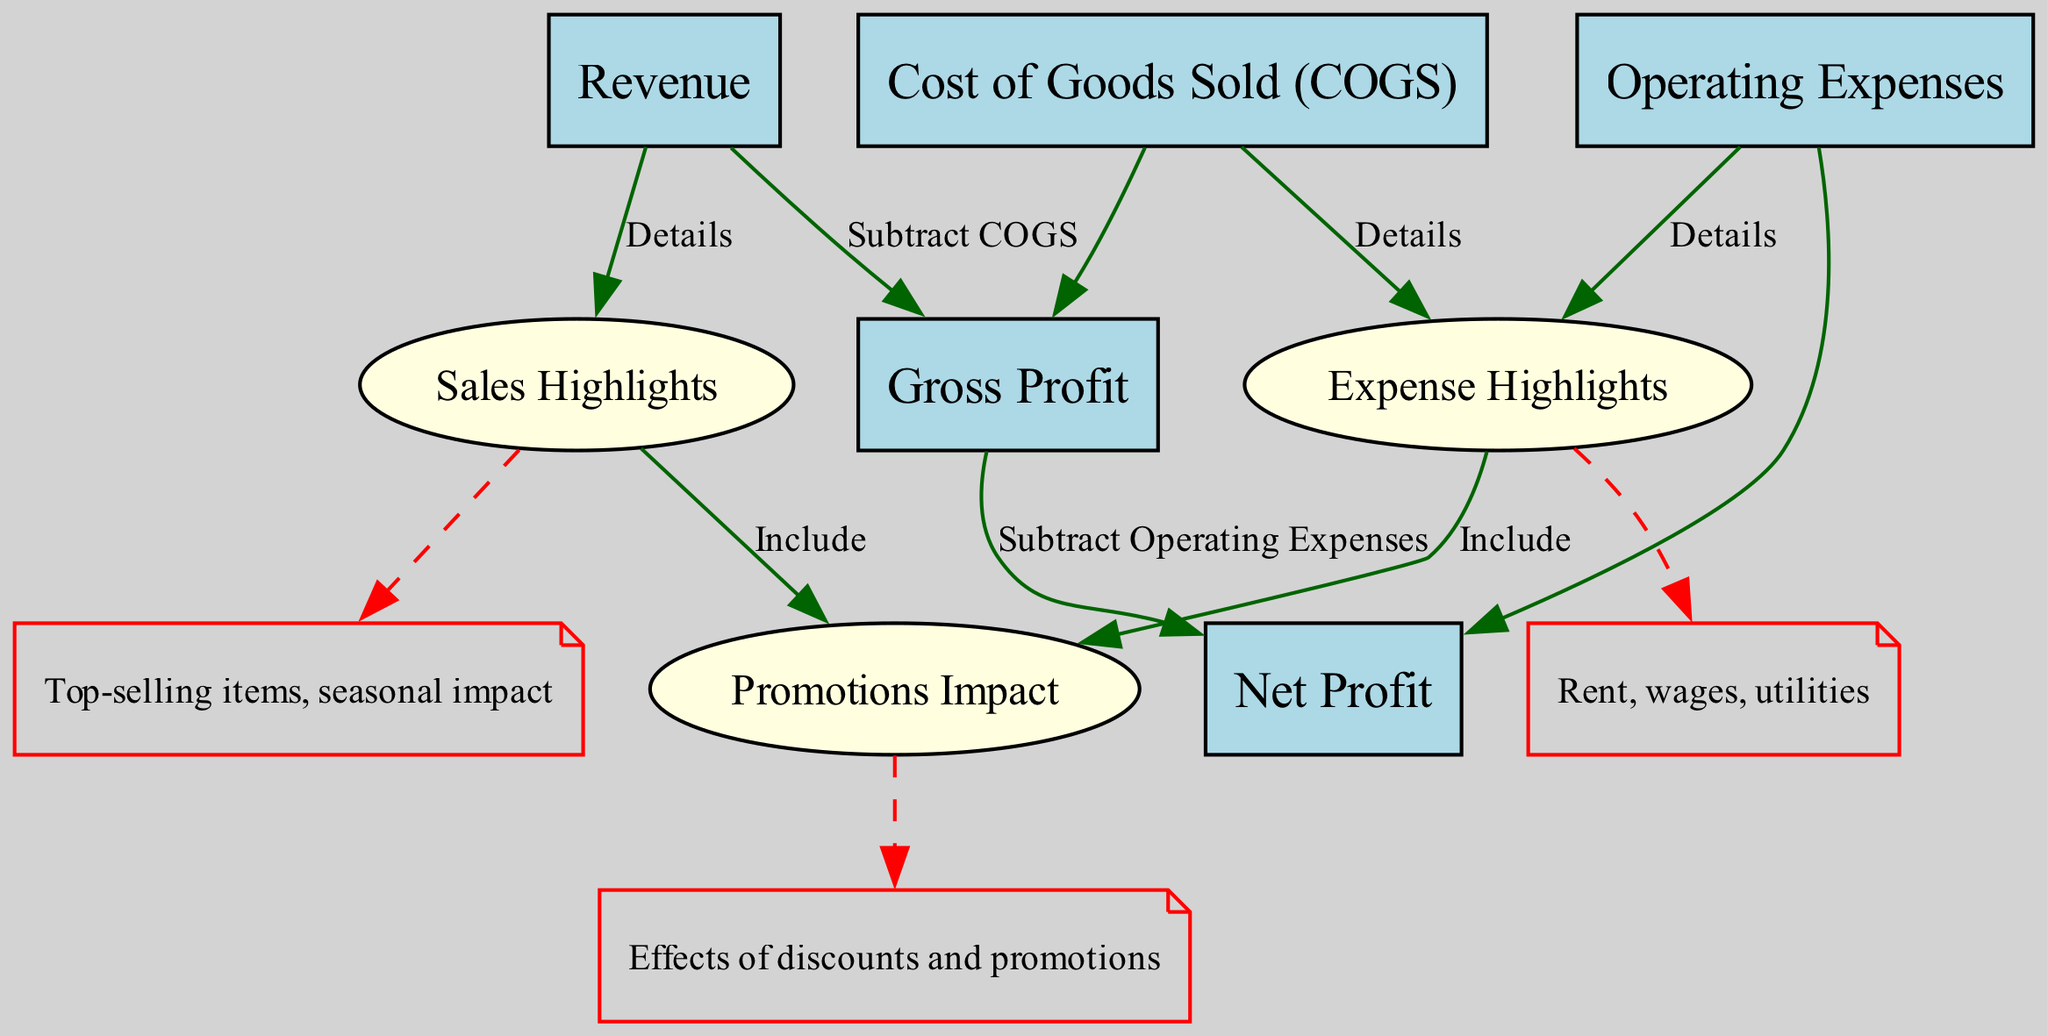what are the key highlights related to sales? The key highlights related to sales can be found in node six, which indicates "Top-selling items, seasonal impact."
Answer: Top-selling items, seasonal impact how do we calculate Gross Profit from Revenue? To calculate Gross Profit, we subtract Cost of Goods Sold from Revenue. This relationship is depicted in the edge connecting node one (Revenue) to node three (Gross Profit) with the label "Subtract COGS."
Answer: Subtract COGS what expenses contribute to the Expense Highlights? The Expense Highlights, as indicated in node seven, include rent, wages, and utilities.
Answer: Rent, wages, utilities what is the relationship between Gross Profit and Net Profit? The relationship is that we subtract Operating Expenses from Gross Profit to arrive at Net Profit. This is represented by the edge connecting node three (Gross Profit) to node five (Net Profit).
Answer: Subtract Operating Expenses how many nodes are present in the diagram? There are eight nodes represented in the diagram, with labels ranging from Revenue to Promotions Impact.
Answer: Eight what influences Promotions Impact in the deli? Promotions Impact is influenced by the details related to sales and expenses, as indicated by the dashed lines connecting nodes six and seven to node eight (Promotions Impact).
Answer: Effects of discounts and promotions what is the formula to find Net Profit? The formula to find Net Profit is Net Profit equals Gross Profit minus Operating Expenses. This flow is clear from the relationship between node three (Gross Profit) and node five (Net Profit).
Answer: Gross Profit minus Operating Expenses which two categories are included in Expense Highlights? The Expense Highlights detail the major costs, specifically rent and wages among others, as shown in node seven.
Answer: Rent, wages what are the main nodes from which Net Profit derives its calculation? Net Profit derives its calculation from Gross Profit and Operating Expenses, as shown by the edges leading to node five from nodes three and four.
Answer: Gross Profit and Operating Expenses 